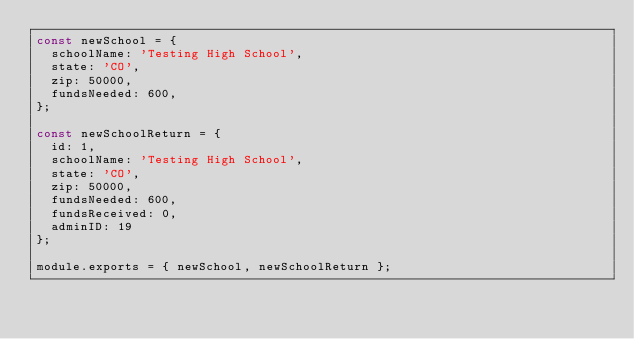<code> <loc_0><loc_0><loc_500><loc_500><_JavaScript_>const newSchool = {
  schoolName: 'Testing High School',
  state: 'CO',
  zip: 50000,
  fundsNeeded: 600,
};

const newSchoolReturn = {
  id: 1,
  schoolName: 'Testing High School',
  state: 'CO',
  zip: 50000,
  fundsNeeded: 600,
  fundsReceived: 0,
  adminID: 19
};

module.exports = { newSchool, newSchoolReturn };
</code> 